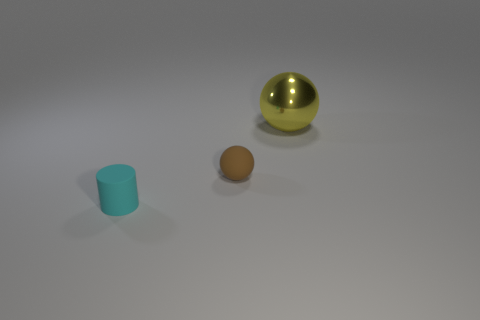Can you infer anything about the texture of the surfaces of the objects shown? Certainly, the large sphere has a glossy, reflective surface that is indicative of it being smooth and perhaps metallic. The small cylinder appears to have a matte finish, suggesting a non-reflective, likely textured surface. The yellow ball falls in between, with a slight sheen that hints at a smooth, but non-metallic surface. 